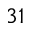<formula> <loc_0><loc_0><loc_500><loc_500>^ { 3 1 }</formula> 